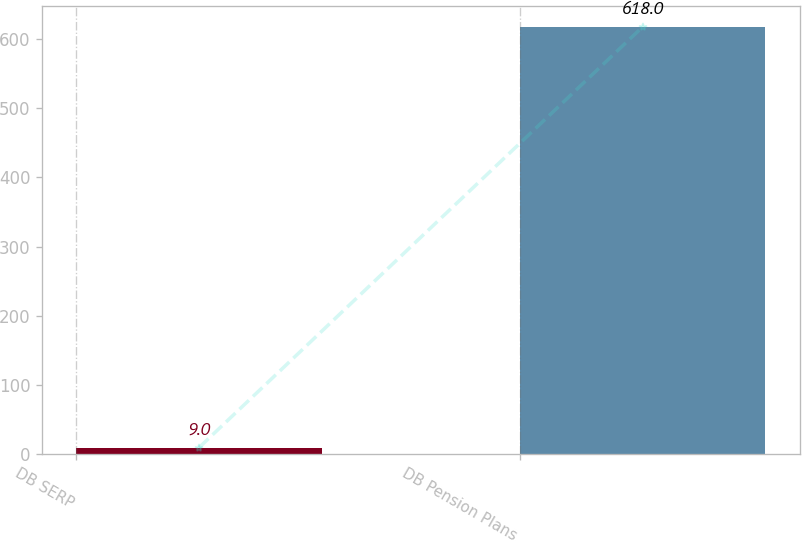<chart> <loc_0><loc_0><loc_500><loc_500><bar_chart><fcel>DB SERP<fcel>DB Pension Plans<nl><fcel>9<fcel>618<nl></chart> 